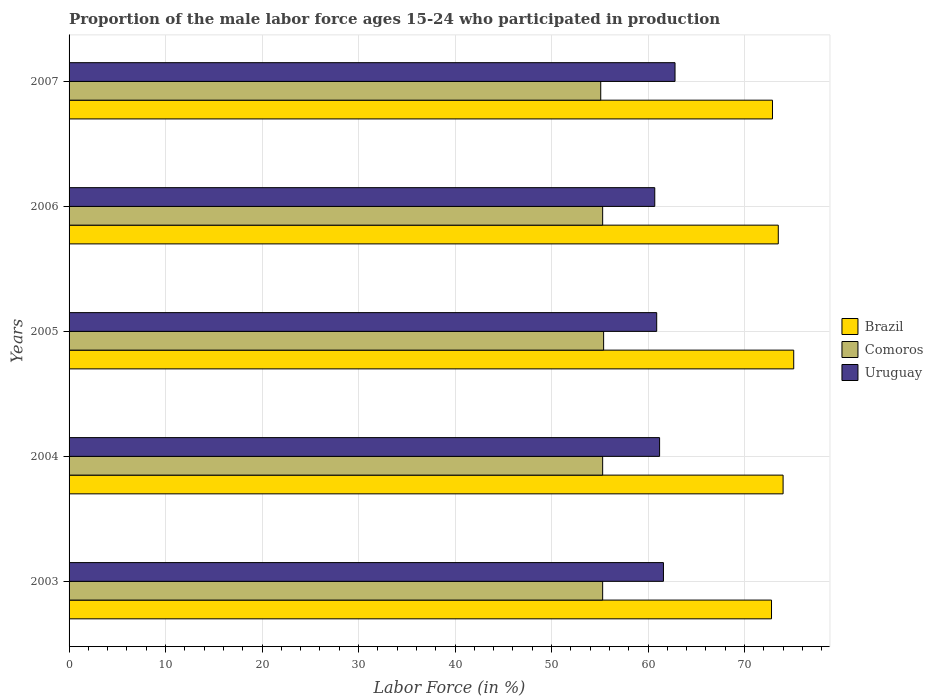Are the number of bars on each tick of the Y-axis equal?
Provide a short and direct response. Yes. How many bars are there on the 4th tick from the top?
Your response must be concise. 3. How many bars are there on the 3rd tick from the bottom?
Make the answer very short. 3. What is the label of the 1st group of bars from the top?
Keep it short and to the point. 2007. What is the proportion of the male labor force who participated in production in Comoros in 2003?
Offer a very short reply. 55.3. Across all years, what is the maximum proportion of the male labor force who participated in production in Brazil?
Give a very brief answer. 75.1. Across all years, what is the minimum proportion of the male labor force who participated in production in Uruguay?
Your answer should be compact. 60.7. In which year was the proportion of the male labor force who participated in production in Brazil minimum?
Provide a short and direct response. 2003. What is the total proportion of the male labor force who participated in production in Comoros in the graph?
Your response must be concise. 276.4. What is the difference between the proportion of the male labor force who participated in production in Uruguay in 2003 and that in 2007?
Provide a short and direct response. -1.2. What is the difference between the proportion of the male labor force who participated in production in Uruguay in 2006 and the proportion of the male labor force who participated in production in Comoros in 2007?
Provide a succinct answer. 5.6. What is the average proportion of the male labor force who participated in production in Comoros per year?
Your answer should be compact. 55.28. In the year 2003, what is the difference between the proportion of the male labor force who participated in production in Uruguay and proportion of the male labor force who participated in production in Brazil?
Make the answer very short. -11.2. In how many years, is the proportion of the male labor force who participated in production in Comoros greater than 2 %?
Offer a very short reply. 5. What is the ratio of the proportion of the male labor force who participated in production in Brazil in 2003 to that in 2006?
Your answer should be very brief. 0.99. What is the difference between the highest and the second highest proportion of the male labor force who participated in production in Brazil?
Ensure brevity in your answer.  1.1. What is the difference between the highest and the lowest proportion of the male labor force who participated in production in Uruguay?
Give a very brief answer. 2.1. What does the 1st bar from the top in 2006 represents?
Give a very brief answer. Uruguay. What does the 2nd bar from the bottom in 2003 represents?
Keep it short and to the point. Comoros. What is the difference between two consecutive major ticks on the X-axis?
Keep it short and to the point. 10. Are the values on the major ticks of X-axis written in scientific E-notation?
Provide a short and direct response. No. Does the graph contain any zero values?
Your response must be concise. No. Does the graph contain grids?
Your response must be concise. Yes. How many legend labels are there?
Your answer should be very brief. 3. What is the title of the graph?
Provide a short and direct response. Proportion of the male labor force ages 15-24 who participated in production. What is the label or title of the X-axis?
Your answer should be very brief. Labor Force (in %). What is the label or title of the Y-axis?
Offer a terse response. Years. What is the Labor Force (in %) in Brazil in 2003?
Your answer should be very brief. 72.8. What is the Labor Force (in %) of Comoros in 2003?
Your response must be concise. 55.3. What is the Labor Force (in %) in Uruguay in 2003?
Offer a very short reply. 61.6. What is the Labor Force (in %) of Comoros in 2004?
Provide a short and direct response. 55.3. What is the Labor Force (in %) of Uruguay in 2004?
Your answer should be very brief. 61.2. What is the Labor Force (in %) of Brazil in 2005?
Your answer should be compact. 75.1. What is the Labor Force (in %) of Comoros in 2005?
Offer a terse response. 55.4. What is the Labor Force (in %) of Uruguay in 2005?
Make the answer very short. 60.9. What is the Labor Force (in %) of Brazil in 2006?
Offer a very short reply. 73.5. What is the Labor Force (in %) in Comoros in 2006?
Your response must be concise. 55.3. What is the Labor Force (in %) in Uruguay in 2006?
Give a very brief answer. 60.7. What is the Labor Force (in %) in Brazil in 2007?
Make the answer very short. 72.9. What is the Labor Force (in %) of Comoros in 2007?
Give a very brief answer. 55.1. What is the Labor Force (in %) in Uruguay in 2007?
Offer a very short reply. 62.8. Across all years, what is the maximum Labor Force (in %) in Brazil?
Offer a very short reply. 75.1. Across all years, what is the maximum Labor Force (in %) of Comoros?
Ensure brevity in your answer.  55.4. Across all years, what is the maximum Labor Force (in %) in Uruguay?
Offer a very short reply. 62.8. Across all years, what is the minimum Labor Force (in %) in Brazil?
Your answer should be very brief. 72.8. Across all years, what is the minimum Labor Force (in %) in Comoros?
Give a very brief answer. 55.1. Across all years, what is the minimum Labor Force (in %) in Uruguay?
Keep it short and to the point. 60.7. What is the total Labor Force (in %) of Brazil in the graph?
Make the answer very short. 368.3. What is the total Labor Force (in %) of Comoros in the graph?
Offer a terse response. 276.4. What is the total Labor Force (in %) in Uruguay in the graph?
Provide a short and direct response. 307.2. What is the difference between the Labor Force (in %) in Brazil in 2003 and that in 2004?
Offer a terse response. -1.2. What is the difference between the Labor Force (in %) of Comoros in 2003 and that in 2004?
Keep it short and to the point. 0. What is the difference between the Labor Force (in %) in Uruguay in 2003 and that in 2004?
Offer a terse response. 0.4. What is the difference between the Labor Force (in %) of Brazil in 2003 and that in 2005?
Make the answer very short. -2.3. What is the difference between the Labor Force (in %) in Uruguay in 2003 and that in 2005?
Offer a very short reply. 0.7. What is the difference between the Labor Force (in %) in Comoros in 2003 and that in 2006?
Your response must be concise. 0. What is the difference between the Labor Force (in %) of Uruguay in 2003 and that in 2006?
Offer a terse response. 0.9. What is the difference between the Labor Force (in %) in Brazil in 2003 and that in 2007?
Offer a terse response. -0.1. What is the difference between the Labor Force (in %) in Comoros in 2003 and that in 2007?
Offer a very short reply. 0.2. What is the difference between the Labor Force (in %) in Brazil in 2004 and that in 2005?
Your response must be concise. -1.1. What is the difference between the Labor Force (in %) in Comoros in 2004 and that in 2006?
Keep it short and to the point. 0. What is the difference between the Labor Force (in %) of Uruguay in 2004 and that in 2006?
Provide a succinct answer. 0.5. What is the difference between the Labor Force (in %) of Brazil in 2004 and that in 2007?
Your answer should be compact. 1.1. What is the difference between the Labor Force (in %) in Uruguay in 2004 and that in 2007?
Your answer should be very brief. -1.6. What is the difference between the Labor Force (in %) of Brazil in 2005 and that in 2006?
Offer a very short reply. 1.6. What is the difference between the Labor Force (in %) in Comoros in 2005 and that in 2006?
Provide a succinct answer. 0.1. What is the difference between the Labor Force (in %) in Brazil in 2005 and that in 2007?
Your answer should be compact. 2.2. What is the difference between the Labor Force (in %) of Brazil in 2006 and that in 2007?
Give a very brief answer. 0.6. What is the difference between the Labor Force (in %) in Brazil in 2003 and the Labor Force (in %) in Comoros in 2004?
Offer a very short reply. 17.5. What is the difference between the Labor Force (in %) of Brazil in 2003 and the Labor Force (in %) of Uruguay in 2004?
Offer a very short reply. 11.6. What is the difference between the Labor Force (in %) in Comoros in 2003 and the Labor Force (in %) in Uruguay in 2004?
Ensure brevity in your answer.  -5.9. What is the difference between the Labor Force (in %) of Brazil in 2003 and the Labor Force (in %) of Uruguay in 2005?
Make the answer very short. 11.9. What is the difference between the Labor Force (in %) in Brazil in 2003 and the Labor Force (in %) in Comoros in 2006?
Keep it short and to the point. 17.5. What is the difference between the Labor Force (in %) of Brazil in 2003 and the Labor Force (in %) of Uruguay in 2006?
Your answer should be compact. 12.1. What is the difference between the Labor Force (in %) in Comoros in 2003 and the Labor Force (in %) in Uruguay in 2006?
Your response must be concise. -5.4. What is the difference between the Labor Force (in %) in Brazil in 2003 and the Labor Force (in %) in Comoros in 2007?
Provide a succinct answer. 17.7. What is the difference between the Labor Force (in %) of Brazil in 2003 and the Labor Force (in %) of Uruguay in 2007?
Your answer should be compact. 10. What is the difference between the Labor Force (in %) in Comoros in 2003 and the Labor Force (in %) in Uruguay in 2007?
Make the answer very short. -7.5. What is the difference between the Labor Force (in %) of Brazil in 2004 and the Labor Force (in %) of Comoros in 2005?
Ensure brevity in your answer.  18.6. What is the difference between the Labor Force (in %) in Comoros in 2004 and the Labor Force (in %) in Uruguay in 2005?
Offer a very short reply. -5.6. What is the difference between the Labor Force (in %) in Brazil in 2004 and the Labor Force (in %) in Comoros in 2006?
Your answer should be compact. 18.7. What is the difference between the Labor Force (in %) in Brazil in 2004 and the Labor Force (in %) in Uruguay in 2006?
Provide a short and direct response. 13.3. What is the difference between the Labor Force (in %) of Comoros in 2004 and the Labor Force (in %) of Uruguay in 2006?
Offer a terse response. -5.4. What is the difference between the Labor Force (in %) in Brazil in 2004 and the Labor Force (in %) in Uruguay in 2007?
Provide a short and direct response. 11.2. What is the difference between the Labor Force (in %) in Comoros in 2004 and the Labor Force (in %) in Uruguay in 2007?
Keep it short and to the point. -7.5. What is the difference between the Labor Force (in %) in Brazil in 2005 and the Labor Force (in %) in Comoros in 2006?
Your answer should be very brief. 19.8. What is the difference between the Labor Force (in %) of Comoros in 2005 and the Labor Force (in %) of Uruguay in 2006?
Make the answer very short. -5.3. What is the difference between the Labor Force (in %) in Brazil in 2005 and the Labor Force (in %) in Comoros in 2007?
Keep it short and to the point. 20. What is the difference between the Labor Force (in %) in Comoros in 2005 and the Labor Force (in %) in Uruguay in 2007?
Make the answer very short. -7.4. What is the difference between the Labor Force (in %) in Brazil in 2006 and the Labor Force (in %) in Comoros in 2007?
Your answer should be compact. 18.4. What is the average Labor Force (in %) of Brazil per year?
Offer a terse response. 73.66. What is the average Labor Force (in %) in Comoros per year?
Offer a terse response. 55.28. What is the average Labor Force (in %) in Uruguay per year?
Offer a very short reply. 61.44. In the year 2003, what is the difference between the Labor Force (in %) in Brazil and Labor Force (in %) in Uruguay?
Offer a terse response. 11.2. In the year 2004, what is the difference between the Labor Force (in %) in Brazil and Labor Force (in %) in Comoros?
Provide a short and direct response. 18.7. In the year 2004, what is the difference between the Labor Force (in %) of Brazil and Labor Force (in %) of Uruguay?
Make the answer very short. 12.8. In the year 2004, what is the difference between the Labor Force (in %) in Comoros and Labor Force (in %) in Uruguay?
Offer a very short reply. -5.9. In the year 2005, what is the difference between the Labor Force (in %) of Brazil and Labor Force (in %) of Uruguay?
Give a very brief answer. 14.2. In the year 2005, what is the difference between the Labor Force (in %) of Comoros and Labor Force (in %) of Uruguay?
Provide a short and direct response. -5.5. In the year 2006, what is the difference between the Labor Force (in %) in Brazil and Labor Force (in %) in Comoros?
Your answer should be very brief. 18.2. In the year 2006, what is the difference between the Labor Force (in %) in Comoros and Labor Force (in %) in Uruguay?
Ensure brevity in your answer.  -5.4. In the year 2007, what is the difference between the Labor Force (in %) of Brazil and Labor Force (in %) of Comoros?
Give a very brief answer. 17.8. In the year 2007, what is the difference between the Labor Force (in %) in Brazil and Labor Force (in %) in Uruguay?
Your answer should be very brief. 10.1. What is the ratio of the Labor Force (in %) in Brazil in 2003 to that in 2004?
Offer a very short reply. 0.98. What is the ratio of the Labor Force (in %) of Comoros in 2003 to that in 2004?
Offer a terse response. 1. What is the ratio of the Labor Force (in %) in Uruguay in 2003 to that in 2004?
Make the answer very short. 1.01. What is the ratio of the Labor Force (in %) of Brazil in 2003 to that in 2005?
Keep it short and to the point. 0.97. What is the ratio of the Labor Force (in %) of Comoros in 2003 to that in 2005?
Ensure brevity in your answer.  1. What is the ratio of the Labor Force (in %) of Uruguay in 2003 to that in 2005?
Provide a succinct answer. 1.01. What is the ratio of the Labor Force (in %) in Comoros in 2003 to that in 2006?
Your answer should be compact. 1. What is the ratio of the Labor Force (in %) in Uruguay in 2003 to that in 2006?
Provide a succinct answer. 1.01. What is the ratio of the Labor Force (in %) in Brazil in 2003 to that in 2007?
Provide a succinct answer. 1. What is the ratio of the Labor Force (in %) of Comoros in 2003 to that in 2007?
Your answer should be very brief. 1. What is the ratio of the Labor Force (in %) of Uruguay in 2003 to that in 2007?
Make the answer very short. 0.98. What is the ratio of the Labor Force (in %) of Brazil in 2004 to that in 2005?
Ensure brevity in your answer.  0.99. What is the ratio of the Labor Force (in %) in Comoros in 2004 to that in 2005?
Your answer should be very brief. 1. What is the ratio of the Labor Force (in %) in Uruguay in 2004 to that in 2005?
Ensure brevity in your answer.  1. What is the ratio of the Labor Force (in %) in Brazil in 2004 to that in 2006?
Offer a terse response. 1.01. What is the ratio of the Labor Force (in %) of Uruguay in 2004 to that in 2006?
Provide a succinct answer. 1.01. What is the ratio of the Labor Force (in %) of Brazil in 2004 to that in 2007?
Keep it short and to the point. 1.02. What is the ratio of the Labor Force (in %) of Uruguay in 2004 to that in 2007?
Make the answer very short. 0.97. What is the ratio of the Labor Force (in %) in Brazil in 2005 to that in 2006?
Provide a succinct answer. 1.02. What is the ratio of the Labor Force (in %) in Uruguay in 2005 to that in 2006?
Your answer should be compact. 1. What is the ratio of the Labor Force (in %) of Brazil in 2005 to that in 2007?
Ensure brevity in your answer.  1.03. What is the ratio of the Labor Force (in %) in Comoros in 2005 to that in 2007?
Provide a short and direct response. 1.01. What is the ratio of the Labor Force (in %) in Uruguay in 2005 to that in 2007?
Your response must be concise. 0.97. What is the ratio of the Labor Force (in %) of Brazil in 2006 to that in 2007?
Give a very brief answer. 1.01. What is the ratio of the Labor Force (in %) of Comoros in 2006 to that in 2007?
Give a very brief answer. 1. What is the ratio of the Labor Force (in %) in Uruguay in 2006 to that in 2007?
Offer a terse response. 0.97. What is the difference between the highest and the second highest Labor Force (in %) in Brazil?
Your answer should be compact. 1.1. What is the difference between the highest and the second highest Labor Force (in %) of Comoros?
Provide a short and direct response. 0.1. What is the difference between the highest and the second highest Labor Force (in %) in Uruguay?
Offer a terse response. 1.2. 